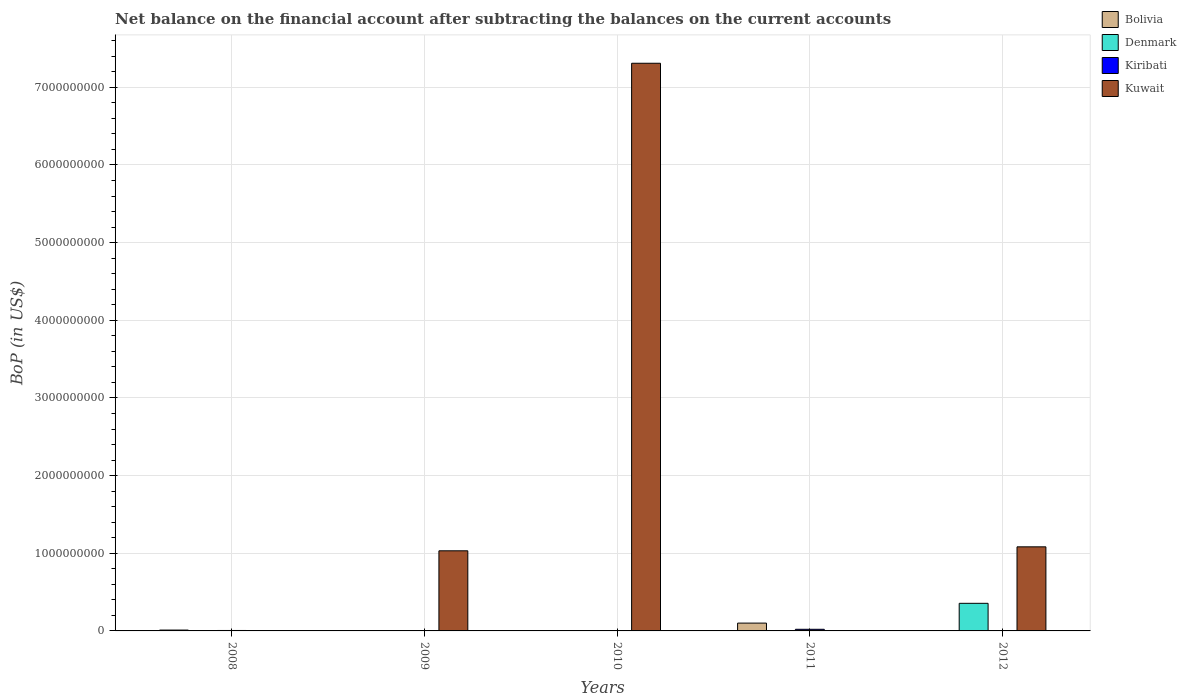Are the number of bars per tick equal to the number of legend labels?
Offer a very short reply. No. Are the number of bars on each tick of the X-axis equal?
Offer a very short reply. No. How many bars are there on the 2nd tick from the left?
Keep it short and to the point. 2. What is the label of the 5th group of bars from the left?
Make the answer very short. 2012. What is the Balance of Payments in Bolivia in 2010?
Make the answer very short. 0. Across all years, what is the maximum Balance of Payments in Kiribati?
Offer a terse response. 2.09e+07. In which year was the Balance of Payments in Kuwait maximum?
Offer a very short reply. 2010. What is the total Balance of Payments in Kuwait in the graph?
Offer a terse response. 9.42e+09. What is the difference between the Balance of Payments in Bolivia in 2008 and that in 2011?
Your answer should be very brief. -8.96e+07. What is the difference between the Balance of Payments in Kiribati in 2010 and the Balance of Payments in Kuwait in 2012?
Keep it short and to the point. -1.08e+09. What is the average Balance of Payments in Kuwait per year?
Provide a short and direct response. 1.88e+09. In the year 2011, what is the difference between the Balance of Payments in Bolivia and Balance of Payments in Kiribati?
Your response must be concise. 7.97e+07. In how many years, is the Balance of Payments in Kuwait greater than 5800000000 US$?
Keep it short and to the point. 1. What is the ratio of the Balance of Payments in Kuwait in 2010 to that in 2012?
Offer a very short reply. 6.75. Is the difference between the Balance of Payments in Bolivia in 2008 and 2011 greater than the difference between the Balance of Payments in Kiribati in 2008 and 2011?
Offer a terse response. No. What is the difference between the highest and the second highest Balance of Payments in Kiribati?
Provide a succinct answer. 1.53e+07. What is the difference between the highest and the lowest Balance of Payments in Kiribati?
Make the answer very short. 2.09e+07. Is it the case that in every year, the sum of the Balance of Payments in Denmark and Balance of Payments in Kiribati is greater than the sum of Balance of Payments in Kuwait and Balance of Payments in Bolivia?
Make the answer very short. No. How many years are there in the graph?
Your answer should be compact. 5. What is the difference between two consecutive major ticks on the Y-axis?
Make the answer very short. 1.00e+09. Are the values on the major ticks of Y-axis written in scientific E-notation?
Offer a very short reply. No. Does the graph contain grids?
Your answer should be compact. Yes. Where does the legend appear in the graph?
Ensure brevity in your answer.  Top right. What is the title of the graph?
Ensure brevity in your answer.  Net balance on the financial account after subtracting the balances on the current accounts. Does "Romania" appear as one of the legend labels in the graph?
Provide a succinct answer. No. What is the label or title of the X-axis?
Provide a short and direct response. Years. What is the label or title of the Y-axis?
Give a very brief answer. BoP (in US$). What is the BoP (in US$) in Bolivia in 2008?
Provide a short and direct response. 1.10e+07. What is the BoP (in US$) in Denmark in 2008?
Your answer should be very brief. 0. What is the BoP (in US$) of Kiribati in 2008?
Keep it short and to the point. 5.63e+06. What is the BoP (in US$) of Bolivia in 2009?
Provide a succinct answer. 0. What is the BoP (in US$) of Kiribati in 2009?
Your answer should be very brief. 4.91e+06. What is the BoP (in US$) of Kuwait in 2009?
Give a very brief answer. 1.03e+09. What is the BoP (in US$) in Denmark in 2010?
Keep it short and to the point. 0. What is the BoP (in US$) of Kuwait in 2010?
Ensure brevity in your answer.  7.31e+09. What is the BoP (in US$) in Bolivia in 2011?
Make the answer very short. 1.01e+08. What is the BoP (in US$) of Kiribati in 2011?
Keep it short and to the point. 2.09e+07. What is the BoP (in US$) in Denmark in 2012?
Give a very brief answer. 3.55e+08. What is the BoP (in US$) in Kiribati in 2012?
Offer a terse response. 2.98e+06. What is the BoP (in US$) in Kuwait in 2012?
Provide a short and direct response. 1.08e+09. Across all years, what is the maximum BoP (in US$) of Bolivia?
Provide a succinct answer. 1.01e+08. Across all years, what is the maximum BoP (in US$) of Denmark?
Your answer should be compact. 3.55e+08. Across all years, what is the maximum BoP (in US$) of Kiribati?
Give a very brief answer. 2.09e+07. Across all years, what is the maximum BoP (in US$) in Kuwait?
Keep it short and to the point. 7.31e+09. Across all years, what is the minimum BoP (in US$) of Denmark?
Provide a succinct answer. 0. Across all years, what is the minimum BoP (in US$) in Kiribati?
Ensure brevity in your answer.  0. What is the total BoP (in US$) in Bolivia in the graph?
Give a very brief answer. 1.12e+08. What is the total BoP (in US$) in Denmark in the graph?
Provide a succinct answer. 3.55e+08. What is the total BoP (in US$) of Kiribati in the graph?
Your response must be concise. 3.44e+07. What is the total BoP (in US$) of Kuwait in the graph?
Your answer should be compact. 9.42e+09. What is the difference between the BoP (in US$) of Kiribati in 2008 and that in 2009?
Your answer should be very brief. 7.15e+05. What is the difference between the BoP (in US$) of Bolivia in 2008 and that in 2011?
Make the answer very short. -8.96e+07. What is the difference between the BoP (in US$) of Kiribati in 2008 and that in 2011?
Make the answer very short. -1.53e+07. What is the difference between the BoP (in US$) in Kiribati in 2008 and that in 2012?
Your answer should be compact. 2.65e+06. What is the difference between the BoP (in US$) in Kuwait in 2009 and that in 2010?
Ensure brevity in your answer.  -6.28e+09. What is the difference between the BoP (in US$) of Kiribati in 2009 and that in 2011?
Provide a succinct answer. -1.60e+07. What is the difference between the BoP (in US$) of Kiribati in 2009 and that in 2012?
Your answer should be compact. 1.94e+06. What is the difference between the BoP (in US$) of Kuwait in 2009 and that in 2012?
Your answer should be compact. -5.13e+07. What is the difference between the BoP (in US$) of Kuwait in 2010 and that in 2012?
Your response must be concise. 6.23e+09. What is the difference between the BoP (in US$) of Kiribati in 2011 and that in 2012?
Offer a terse response. 1.80e+07. What is the difference between the BoP (in US$) in Bolivia in 2008 and the BoP (in US$) in Kiribati in 2009?
Keep it short and to the point. 6.10e+06. What is the difference between the BoP (in US$) in Bolivia in 2008 and the BoP (in US$) in Kuwait in 2009?
Give a very brief answer. -1.02e+09. What is the difference between the BoP (in US$) of Kiribati in 2008 and the BoP (in US$) of Kuwait in 2009?
Your response must be concise. -1.03e+09. What is the difference between the BoP (in US$) in Bolivia in 2008 and the BoP (in US$) in Kuwait in 2010?
Make the answer very short. -7.30e+09. What is the difference between the BoP (in US$) of Kiribati in 2008 and the BoP (in US$) of Kuwait in 2010?
Provide a short and direct response. -7.30e+09. What is the difference between the BoP (in US$) in Bolivia in 2008 and the BoP (in US$) in Kiribati in 2011?
Give a very brief answer. -9.92e+06. What is the difference between the BoP (in US$) of Bolivia in 2008 and the BoP (in US$) of Denmark in 2012?
Make the answer very short. -3.44e+08. What is the difference between the BoP (in US$) of Bolivia in 2008 and the BoP (in US$) of Kiribati in 2012?
Your answer should be very brief. 8.04e+06. What is the difference between the BoP (in US$) in Bolivia in 2008 and the BoP (in US$) in Kuwait in 2012?
Your response must be concise. -1.07e+09. What is the difference between the BoP (in US$) in Kiribati in 2008 and the BoP (in US$) in Kuwait in 2012?
Ensure brevity in your answer.  -1.08e+09. What is the difference between the BoP (in US$) of Kiribati in 2009 and the BoP (in US$) of Kuwait in 2010?
Provide a short and direct response. -7.31e+09. What is the difference between the BoP (in US$) of Kiribati in 2009 and the BoP (in US$) of Kuwait in 2012?
Your answer should be compact. -1.08e+09. What is the difference between the BoP (in US$) of Bolivia in 2011 and the BoP (in US$) of Denmark in 2012?
Give a very brief answer. -2.55e+08. What is the difference between the BoP (in US$) of Bolivia in 2011 and the BoP (in US$) of Kiribati in 2012?
Your response must be concise. 9.77e+07. What is the difference between the BoP (in US$) in Bolivia in 2011 and the BoP (in US$) in Kuwait in 2012?
Give a very brief answer. -9.82e+08. What is the difference between the BoP (in US$) of Kiribati in 2011 and the BoP (in US$) of Kuwait in 2012?
Provide a succinct answer. -1.06e+09. What is the average BoP (in US$) of Bolivia per year?
Make the answer very short. 2.23e+07. What is the average BoP (in US$) of Denmark per year?
Keep it short and to the point. 7.11e+07. What is the average BoP (in US$) in Kiribati per year?
Your answer should be very brief. 6.89e+06. What is the average BoP (in US$) of Kuwait per year?
Your answer should be compact. 1.88e+09. In the year 2008, what is the difference between the BoP (in US$) of Bolivia and BoP (in US$) of Kiribati?
Offer a very short reply. 5.39e+06. In the year 2009, what is the difference between the BoP (in US$) of Kiribati and BoP (in US$) of Kuwait?
Your answer should be compact. -1.03e+09. In the year 2011, what is the difference between the BoP (in US$) of Bolivia and BoP (in US$) of Kiribati?
Provide a short and direct response. 7.97e+07. In the year 2012, what is the difference between the BoP (in US$) of Denmark and BoP (in US$) of Kiribati?
Your answer should be compact. 3.52e+08. In the year 2012, what is the difference between the BoP (in US$) of Denmark and BoP (in US$) of Kuwait?
Offer a very short reply. -7.27e+08. In the year 2012, what is the difference between the BoP (in US$) of Kiribati and BoP (in US$) of Kuwait?
Make the answer very short. -1.08e+09. What is the ratio of the BoP (in US$) of Kiribati in 2008 to that in 2009?
Make the answer very short. 1.15. What is the ratio of the BoP (in US$) of Bolivia in 2008 to that in 2011?
Offer a very short reply. 0.11. What is the ratio of the BoP (in US$) in Kiribati in 2008 to that in 2011?
Give a very brief answer. 0.27. What is the ratio of the BoP (in US$) of Kiribati in 2008 to that in 2012?
Offer a very short reply. 1.89. What is the ratio of the BoP (in US$) of Kuwait in 2009 to that in 2010?
Keep it short and to the point. 0.14. What is the ratio of the BoP (in US$) of Kiribati in 2009 to that in 2011?
Your response must be concise. 0.23. What is the ratio of the BoP (in US$) in Kiribati in 2009 to that in 2012?
Keep it short and to the point. 1.65. What is the ratio of the BoP (in US$) of Kuwait in 2009 to that in 2012?
Your answer should be compact. 0.95. What is the ratio of the BoP (in US$) in Kuwait in 2010 to that in 2012?
Provide a succinct answer. 6.75. What is the ratio of the BoP (in US$) in Kiribati in 2011 to that in 2012?
Your response must be concise. 7.03. What is the difference between the highest and the second highest BoP (in US$) in Kiribati?
Keep it short and to the point. 1.53e+07. What is the difference between the highest and the second highest BoP (in US$) of Kuwait?
Keep it short and to the point. 6.23e+09. What is the difference between the highest and the lowest BoP (in US$) of Bolivia?
Give a very brief answer. 1.01e+08. What is the difference between the highest and the lowest BoP (in US$) of Denmark?
Your answer should be compact. 3.55e+08. What is the difference between the highest and the lowest BoP (in US$) in Kiribati?
Ensure brevity in your answer.  2.09e+07. What is the difference between the highest and the lowest BoP (in US$) of Kuwait?
Provide a short and direct response. 7.31e+09. 